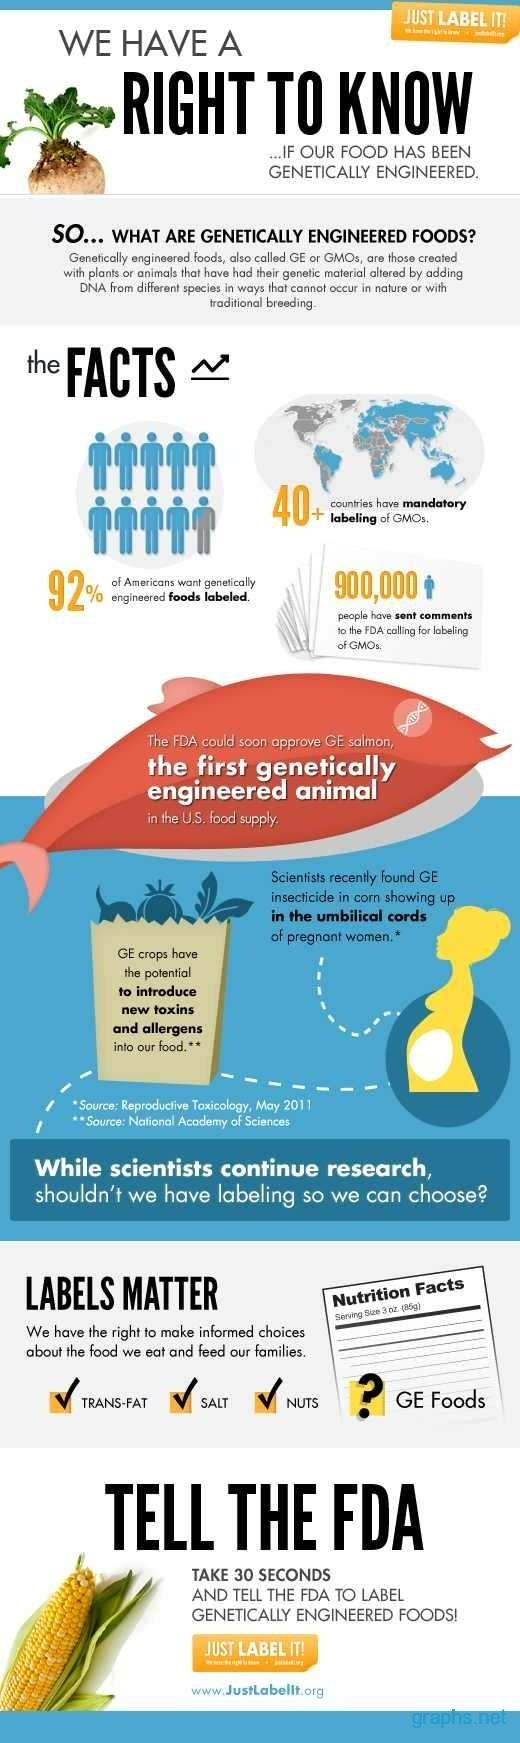List a handful of essential elements in this visual. A recent survey has revealed that only 8% of Americans support food labeling. 